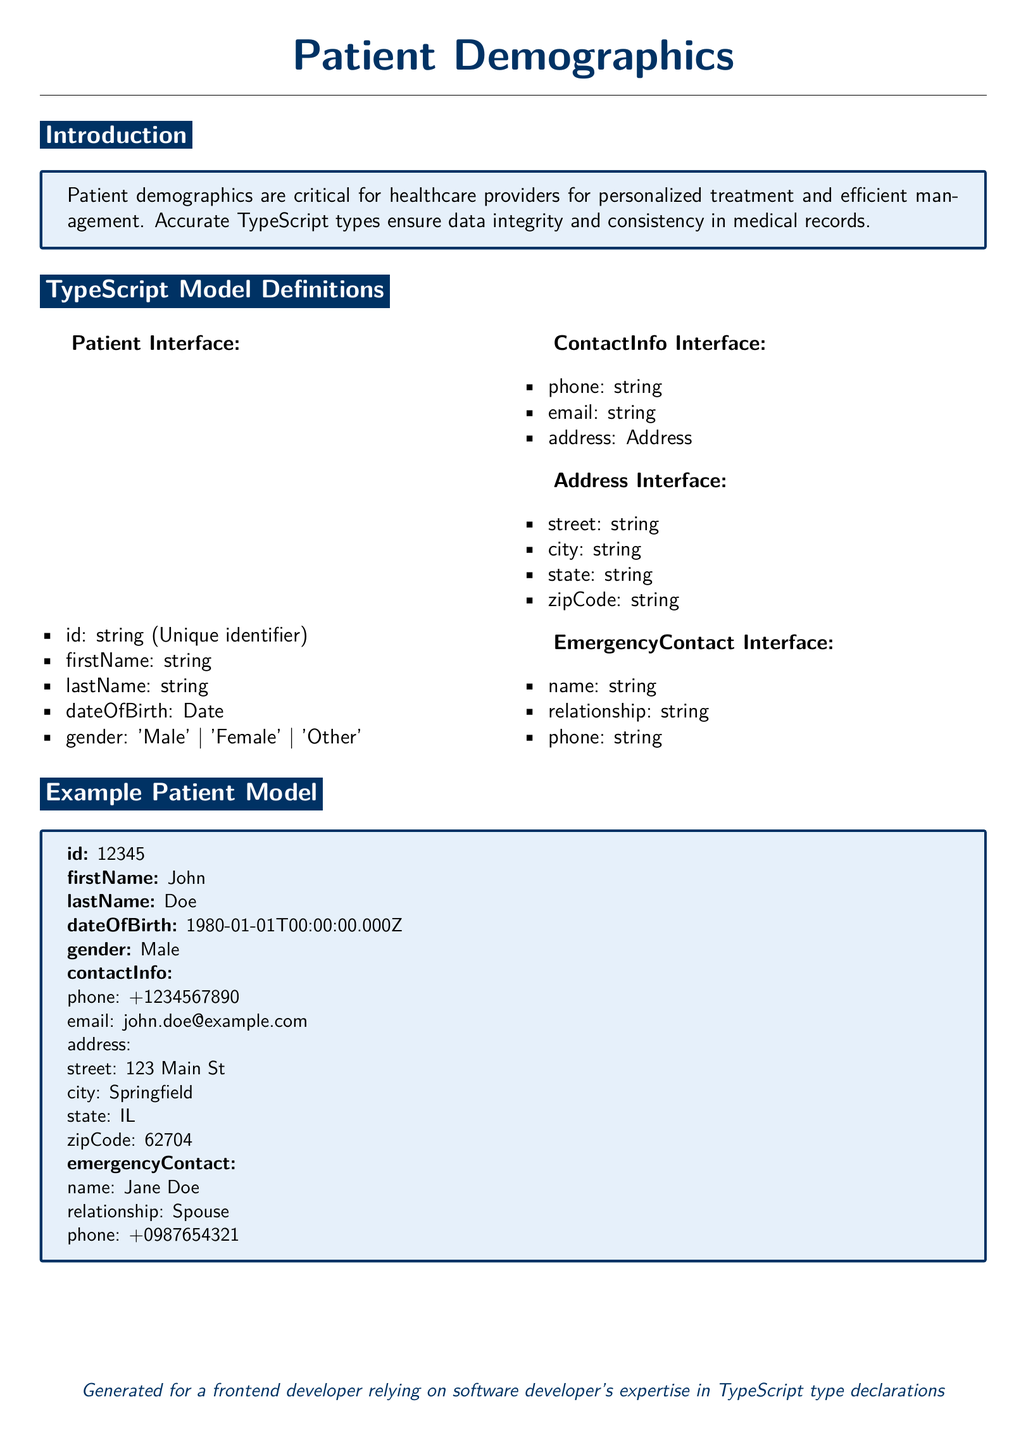What is the patient's first name? The first name of the patient is explicitly stated in the document.
Answer: John What is the patient's gender? The gender of the patient is specified in the demographics section.
Answer: Male Which state does the patient reside in? The patient's state is detailed in the address section of the document.
Answer: IL What is the emergency contact's name? The name of the emergency contact is directly mentioned in the example patient model.
Answer: Jane Doe What is the patient's date of birth? The date of birth can be found in the patient details provided in the document.
Answer: 1980-01-01 How many interfaces are defined in the TypeScript Model Definitions? The document lists multiple interfaces under TypeScript Model Definitions.
Answer: Four What is the patient's last name? The last name of the patient is included in the demographics information.
Answer: Doe What type of document is this? The document type is mentioned in the title.
Answer: Medical record What contact method is included in the contact information? The contact methods are detailed in the ContactInfo Interface.
Answer: Phone and email 